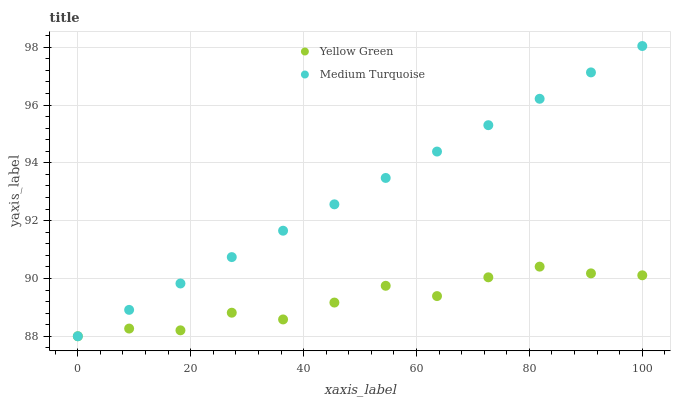Does Yellow Green have the minimum area under the curve?
Answer yes or no. Yes. Does Medium Turquoise have the maximum area under the curve?
Answer yes or no. Yes. Does Medium Turquoise have the minimum area under the curve?
Answer yes or no. No. Is Medium Turquoise the smoothest?
Answer yes or no. Yes. Is Yellow Green the roughest?
Answer yes or no. Yes. Is Medium Turquoise the roughest?
Answer yes or no. No. Does Yellow Green have the lowest value?
Answer yes or no. Yes. Does Medium Turquoise have the highest value?
Answer yes or no. Yes. Does Yellow Green intersect Medium Turquoise?
Answer yes or no. Yes. Is Yellow Green less than Medium Turquoise?
Answer yes or no. No. Is Yellow Green greater than Medium Turquoise?
Answer yes or no. No. 